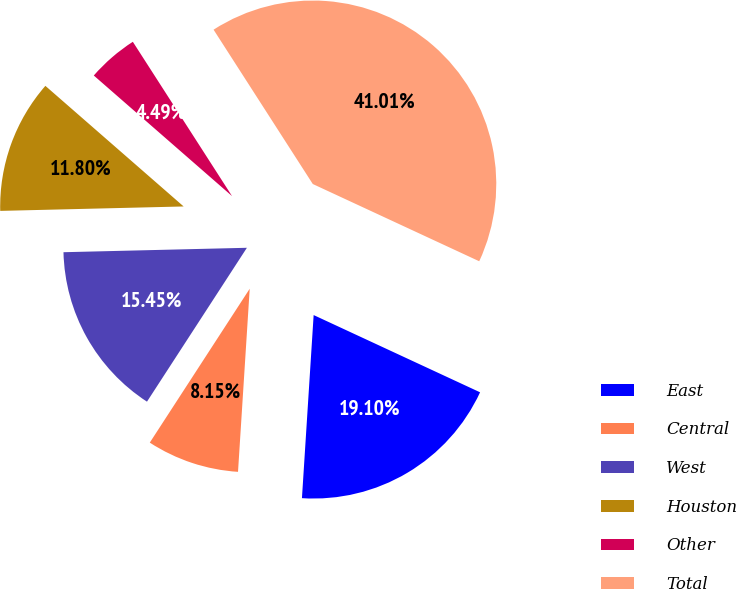Convert chart. <chart><loc_0><loc_0><loc_500><loc_500><pie_chart><fcel>East<fcel>Central<fcel>West<fcel>Houston<fcel>Other<fcel>Total<nl><fcel>19.1%<fcel>8.15%<fcel>15.45%<fcel>11.8%<fcel>4.49%<fcel>41.01%<nl></chart> 